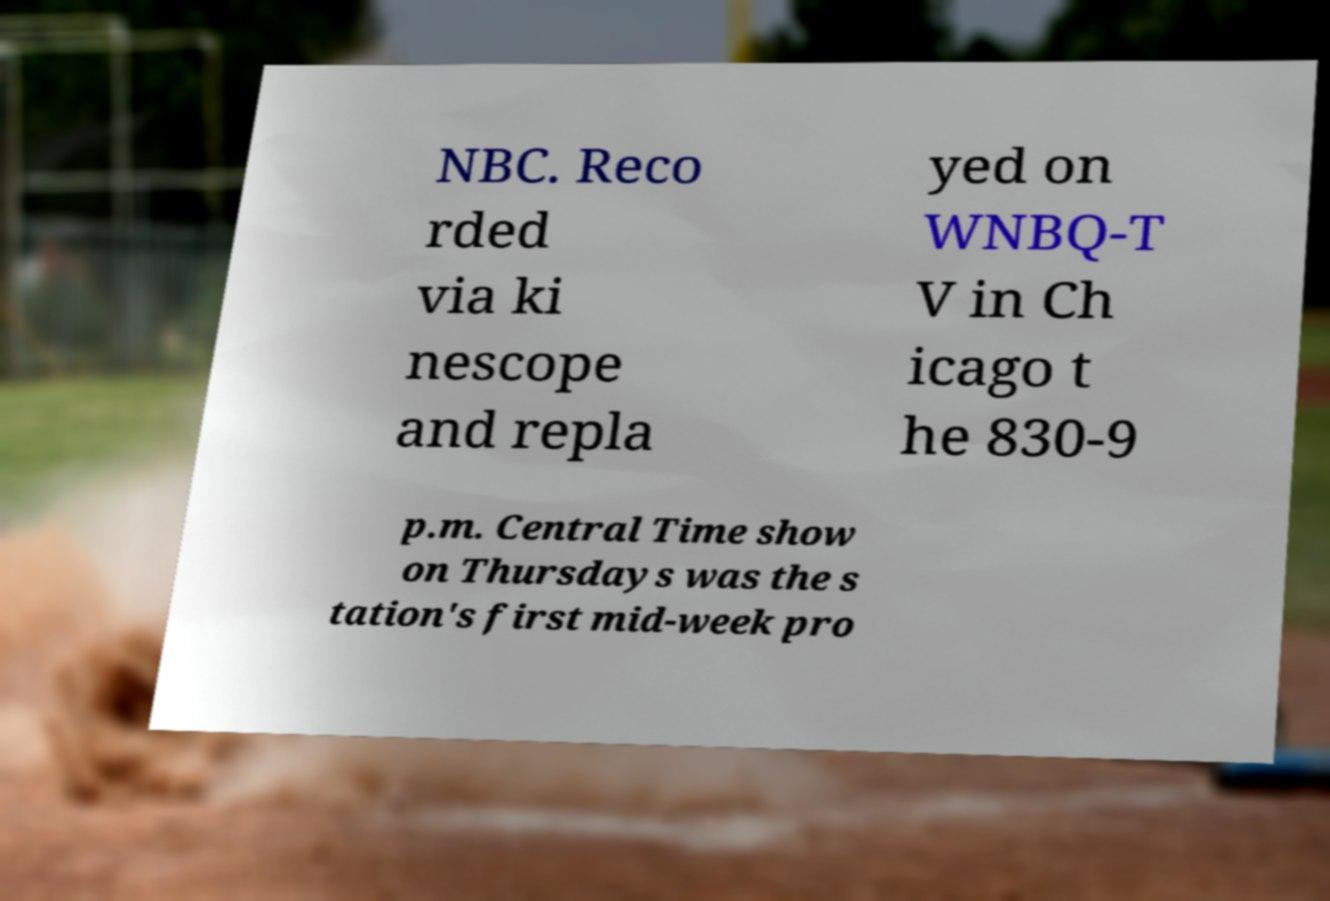Can you read and provide the text displayed in the image?This photo seems to have some interesting text. Can you extract and type it out for me? NBC. Reco rded via ki nescope and repla yed on WNBQ-T V in Ch icago t he 830-9 p.m. Central Time show on Thursdays was the s tation's first mid-week pro 